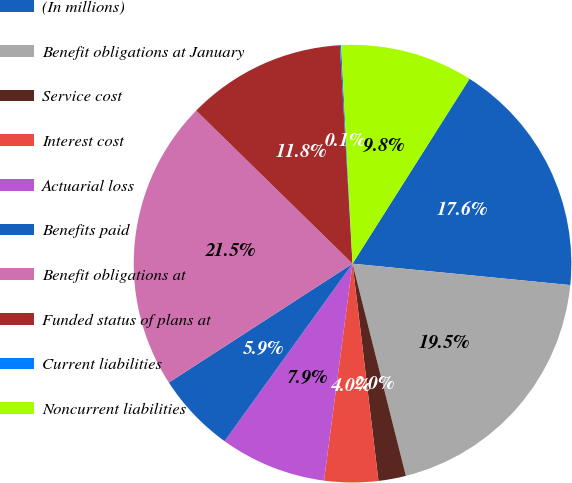<chart> <loc_0><loc_0><loc_500><loc_500><pie_chart><fcel>(In millions)<fcel>Benefit obligations at January<fcel>Service cost<fcel>Interest cost<fcel>Actuarial loss<fcel>Benefits paid<fcel>Benefit obligations at<fcel>Funded status of plans at<fcel>Current liabilities<fcel>Noncurrent liabilities<nl><fcel>17.58%<fcel>19.52%<fcel>2.03%<fcel>3.97%<fcel>7.86%<fcel>5.92%<fcel>21.47%<fcel>11.75%<fcel>0.09%<fcel>9.81%<nl></chart> 